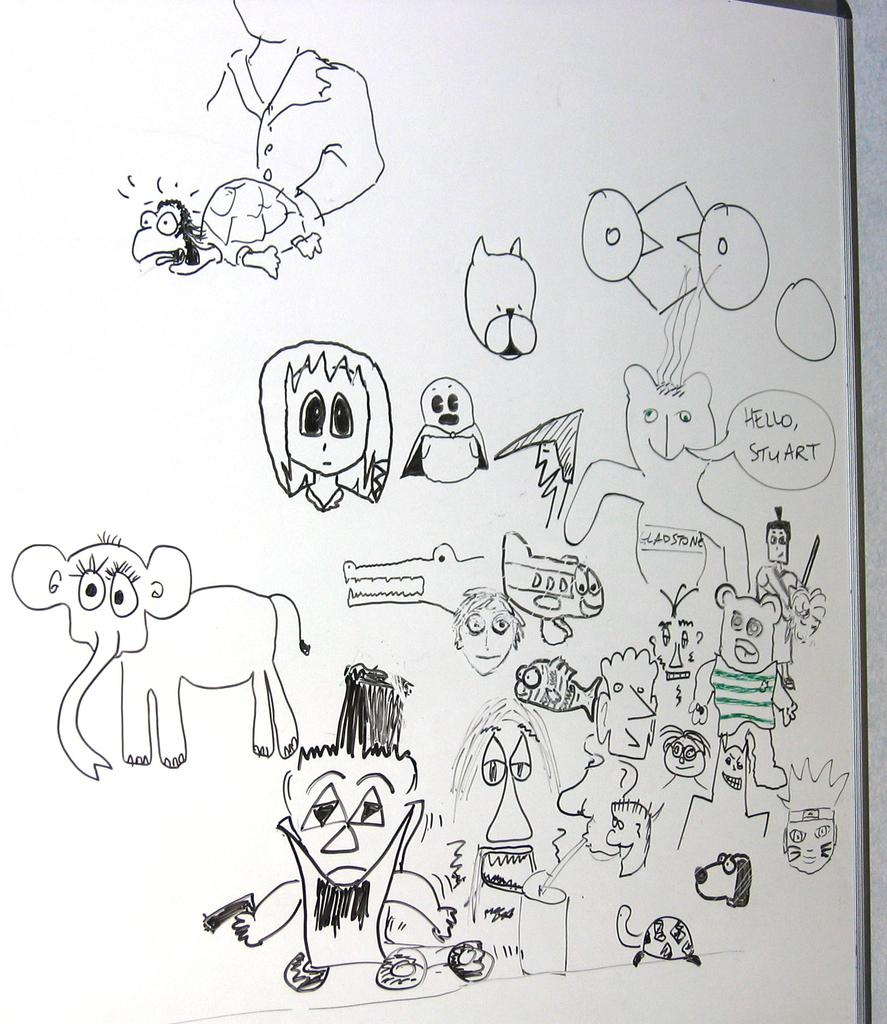What is the main object in the image? There is a board in the image. What can be seen on the board? The board contains drawings of animals. Are there any other drawings or elements on the board besides the animal drawings? Yes, there are other drawings or elements on the board. Is there any text on the board? Yes, there is text on the board. Where is the mailbox located in the image? There is no mailbox present in the image. What type of furniture is depicted in the image? There is no furniture depicted in the image; it features a board with drawings and text. 